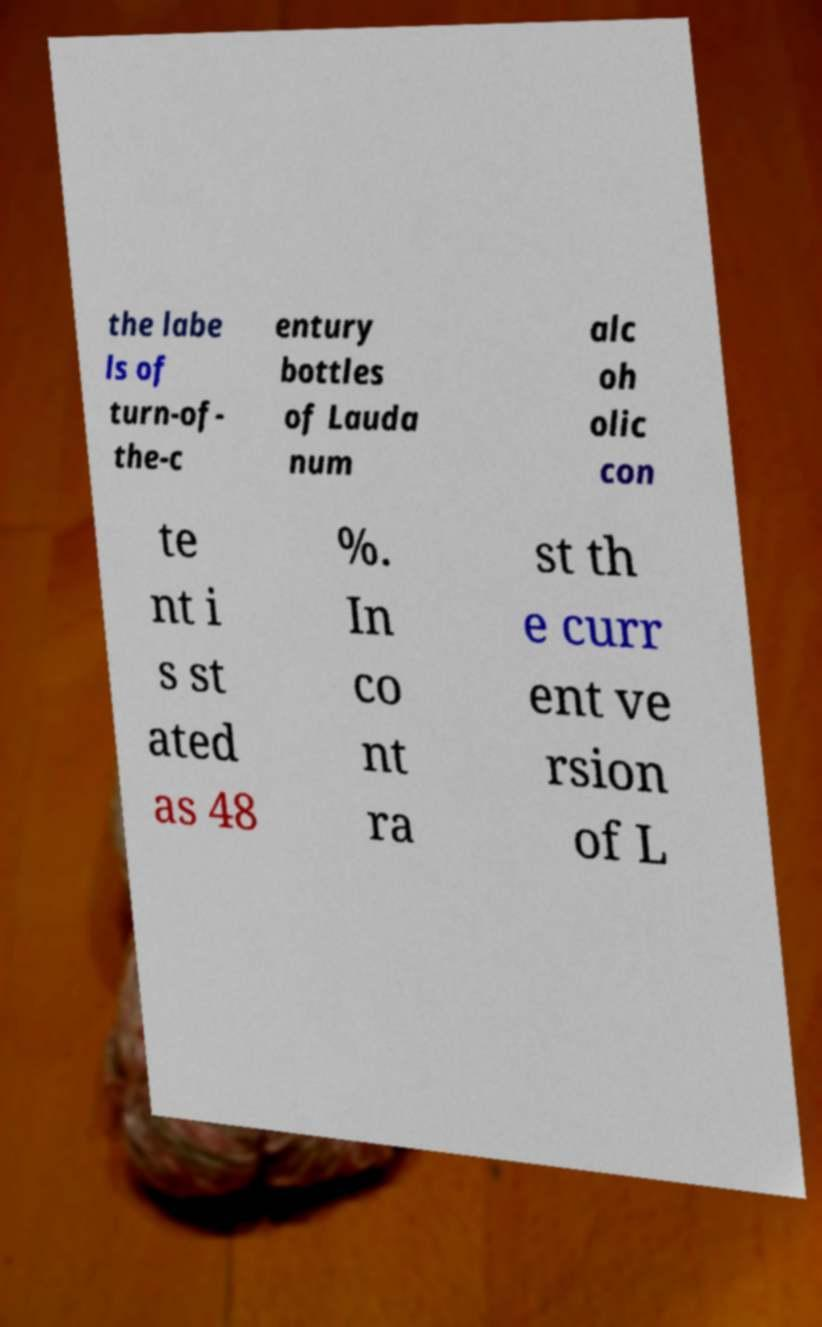Could you extract and type out the text from this image? the labe ls of turn-of- the-c entury bottles of Lauda num alc oh olic con te nt i s st ated as 48 %. In co nt ra st th e curr ent ve rsion of L 